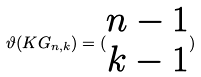<formula> <loc_0><loc_0><loc_500><loc_500>\vartheta ( K G _ { n , k } ) = ( \begin{matrix} n - 1 \\ k - 1 \end{matrix} )</formula> 